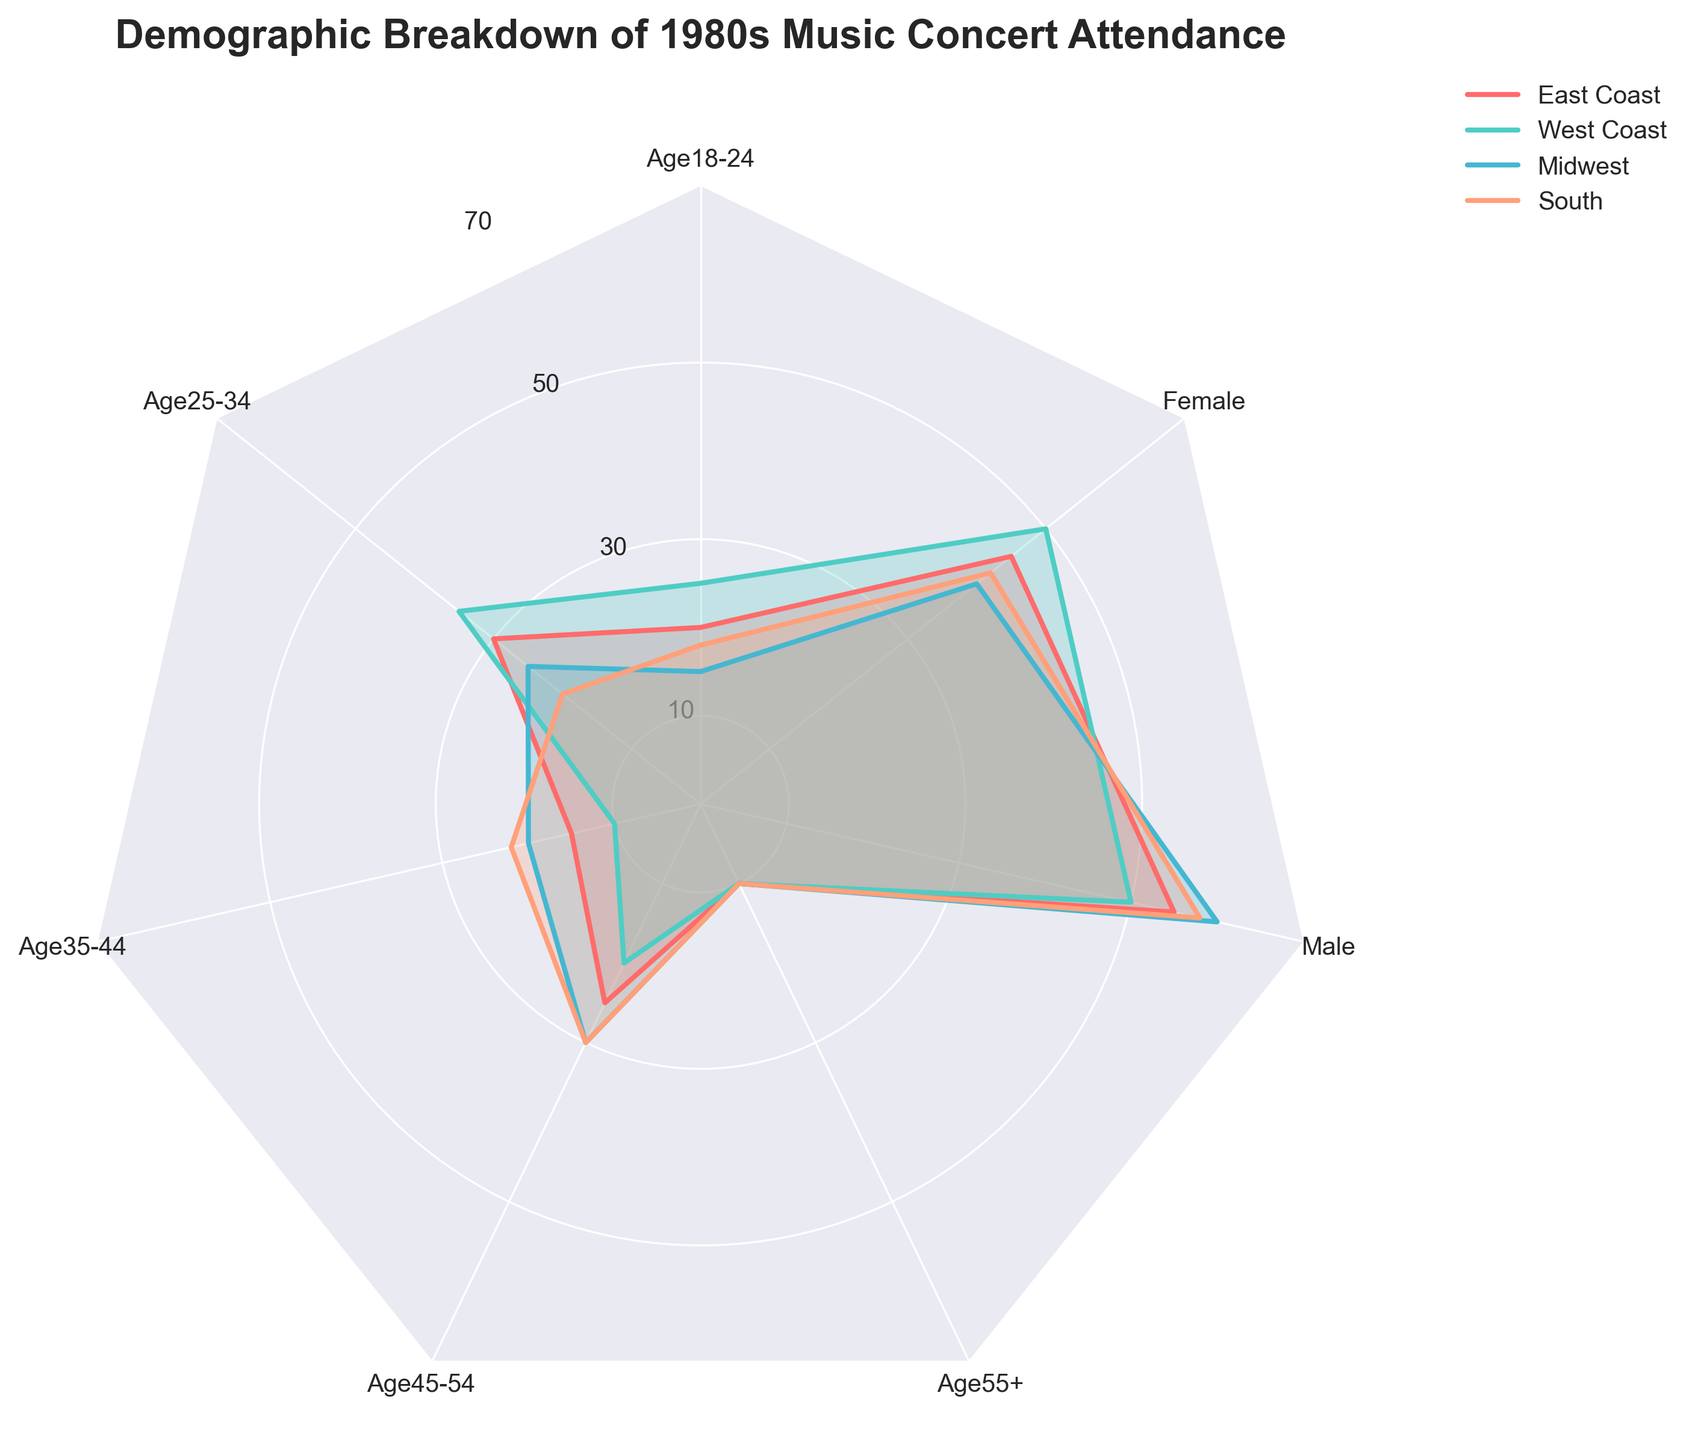What is the title of the radar chart? The title is usually placed at the top of the figure. Here, the title "Demographic Breakdown of 1980s Music Concert Attendance" is prominently displayed.
Answer: Demographic Breakdown of 1980s Music Concert Attendance Which region has the highest concert attendance for the 25-34 age group? By looking at the corresponding segment for the 25-34 age group, we see that the West Coast has the highest value among all regions.
Answer: West Coast How does attendance for the 45-54 age group compare between the East Coast and the Midwest? From the radar chart, the values for the 45-54 age group are 25 for the East Coast and 30 for the Midwest. We see that the Midwest has higher attendance.
Answer: Midwest Which gender had a higher concert attendance overall? The chart shows distinct values for males and females, with males having higher values (around 55-60) compared to females (around 40-50) across all regions.
Answer: Male What is the combined concert attendance of the South for all age groups? For the South, the values are 18 (Age 18-24) + 20 (Age 25-34) + 22 (Age 35-44) + 30 (Age 45-54) + 10 (Age 55+). Summing these up gives 100.
Answer: 100 What is the proportion of males to females in the Midwest? In the Midwest, the value for males is 60, and for females, it is 40. The proportion is calculated as 60/40 = 1.5, meaning there are 1.5 males for every female.
Answer: 1.5 Which regions have equal attendance for the age group 55+? The chart shows that for the 55+ age group, all regions (East Coast, West Coast, Midwest, and South) have a value of 10.
Answer: All regions In which region is the gender distribution closest to equal? By looking at both male and female values, we see the West Coast has values of 50 for both genders, making its gender distribution the closest to equal.
Answer: West Coast Compare the age group 35-44's concert attendance on the East Coast versus the West Coast. On the radar chart, the East Coast has a value of 15, while the West Coast has a lower value of 10 for the 35-44 age group. Thus, the East Coast has a higher attendance for this age group.
Answer: East Coast 